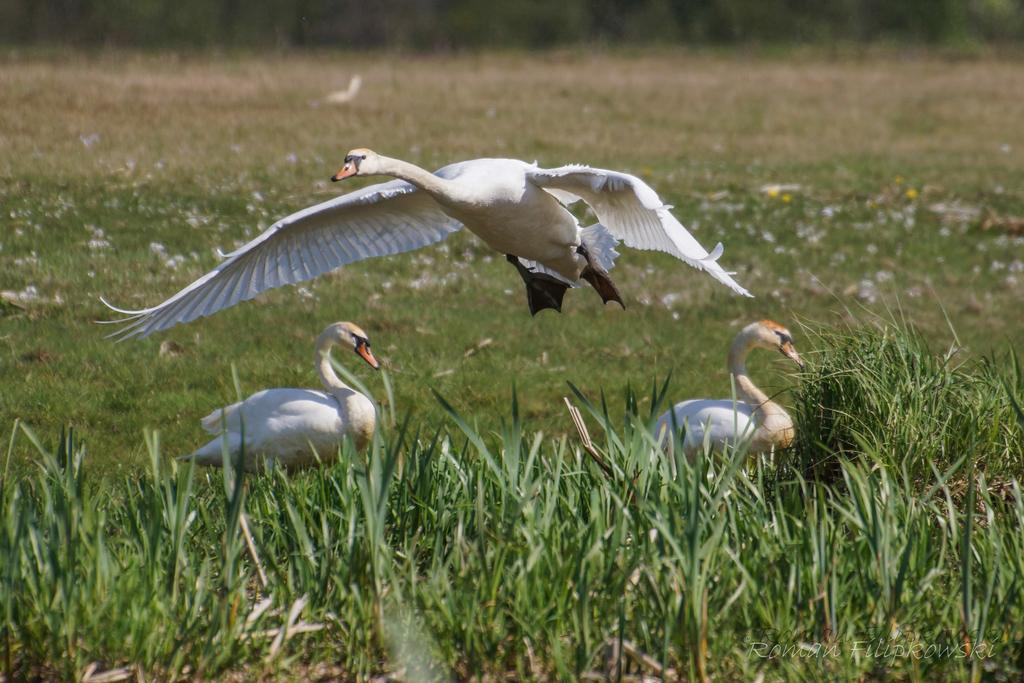How many birds are present in the image? There are three birds in the image. Where are two of the birds located? Two birds are on the ground. What is the third bird doing in the image? One bird is flying. What type of pies are the birds serving in the image? There are no pies or serving actions present in the image; it features three birds, with two on the ground and one flying. 